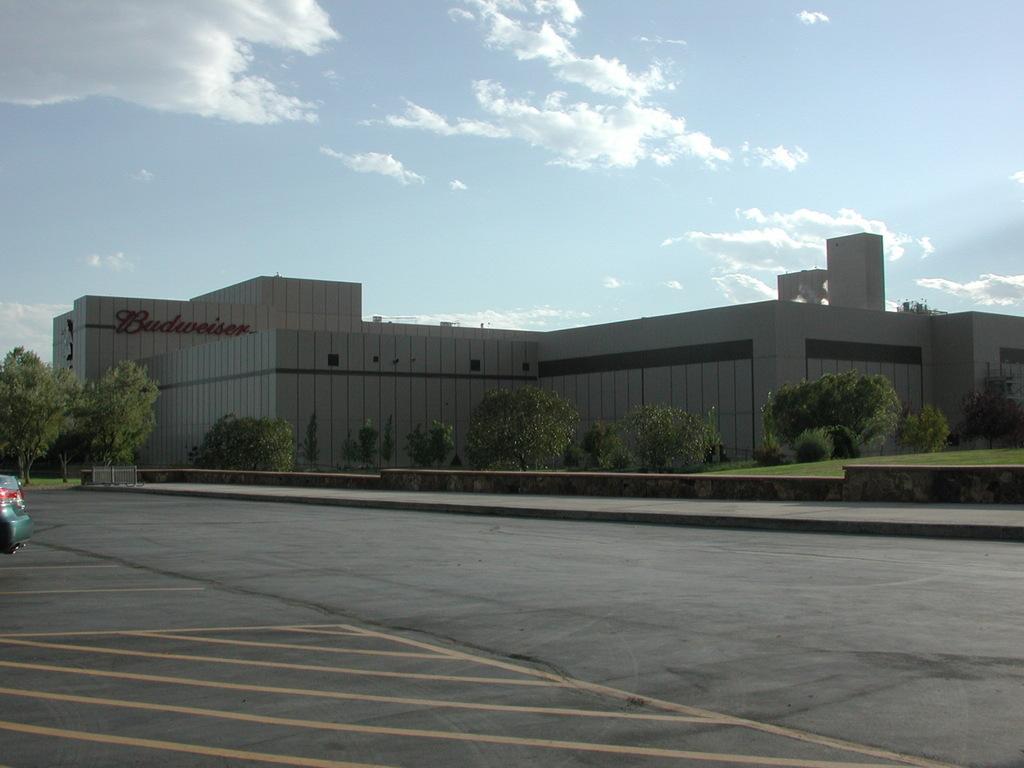Please provide a concise description of this image. In this image we can see a building with some text on it. In the foreground we can see a group of trees and a car parked in a parking lot. In the background, we can see the cloudy sky. 